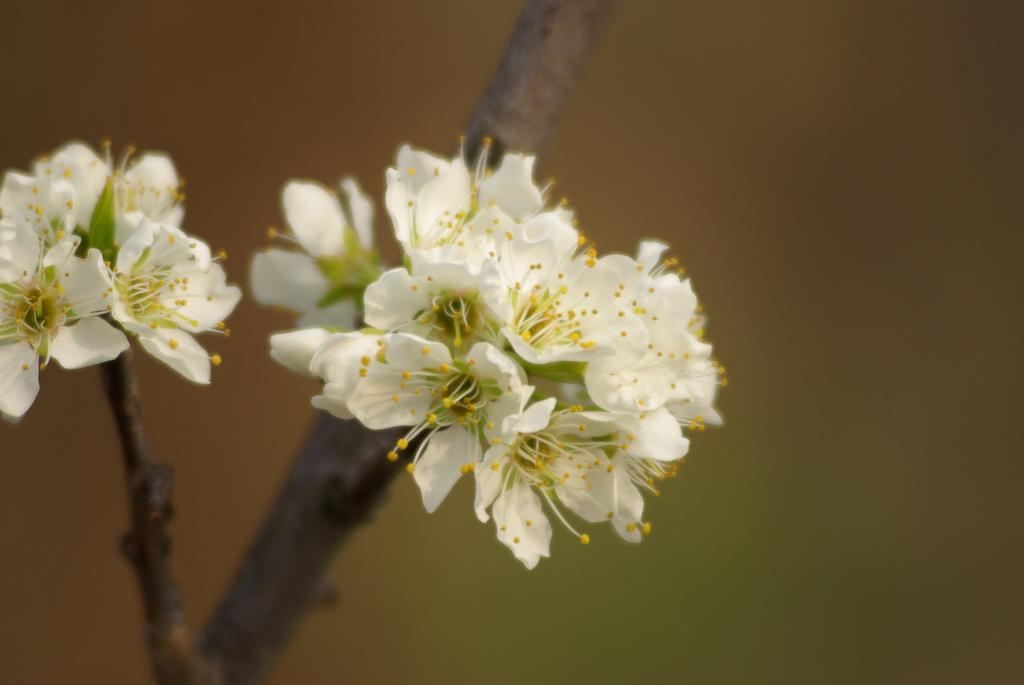What is the main subject of the image? The main subject of the image is a plant. What can be seen on the branches of the plant? Flowers are present on the branches of the plant. What type of liquid can be seen flowing from the back of the plant in the image? There is no liquid flowing from the back of the plant in the image, as it only shows a plant with flowers on its branches. 